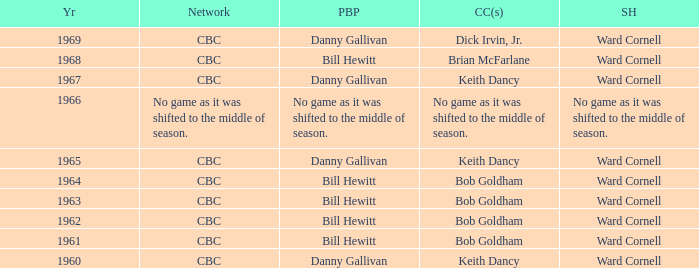Who gave the play by play commentary with studio host Ward Cornell? Danny Gallivan, Bill Hewitt, Danny Gallivan, Danny Gallivan, Bill Hewitt, Bill Hewitt, Bill Hewitt, Bill Hewitt, Danny Gallivan. 